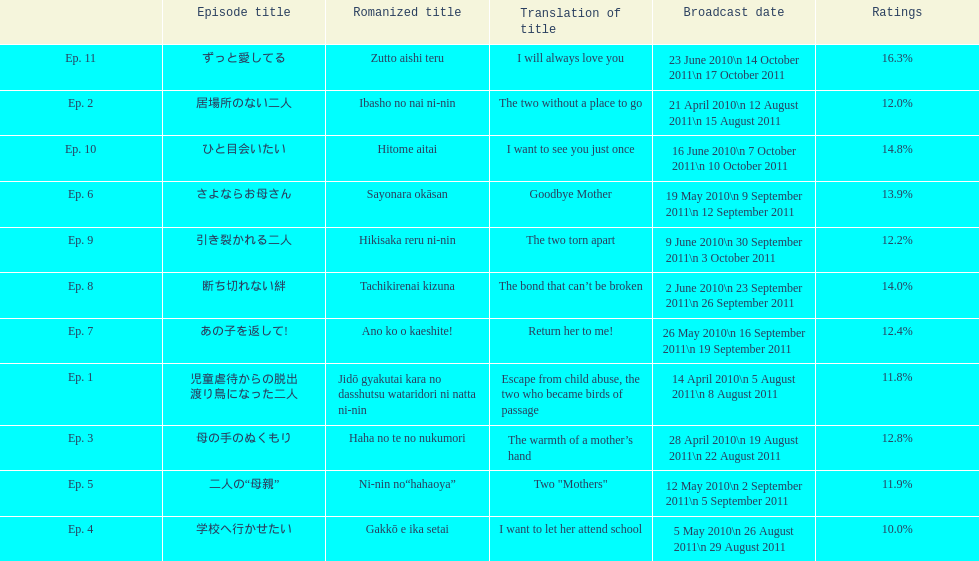What was the name of the next episode after goodbye mother? あの子を返して!. 